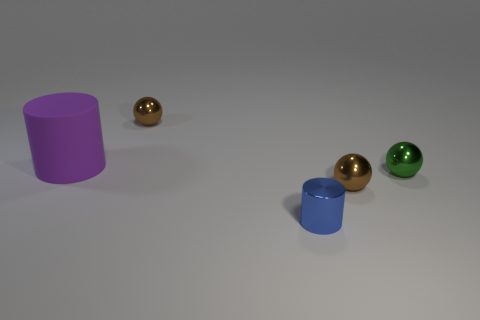Are there an equal number of rubber cylinders that are left of the large matte cylinder and large green rubber spheres?
Offer a terse response. Yes. What number of other things are there of the same material as the small blue cylinder
Offer a terse response. 3. Is the size of the cylinder that is on the right side of the big purple thing the same as the metallic ball that is to the left of the small blue shiny cylinder?
Provide a short and direct response. Yes. What number of objects are either tiny metallic things in front of the big purple cylinder or small brown metallic things behind the green sphere?
Give a very brief answer. 4. Are there any other things that are the same shape as the green thing?
Offer a very short reply. Yes. There is a cylinder left of the tiny blue cylinder; does it have the same color as the shiny thing on the left side of the small blue cylinder?
Your response must be concise. No. How many rubber objects are either green spheres or small blue things?
Your response must be concise. 0. Are there any other things that are the same size as the blue cylinder?
Your answer should be very brief. Yes. What is the shape of the tiny thing in front of the brown object that is in front of the purple matte thing?
Offer a very short reply. Cylinder. Are the brown sphere in front of the purple cylinder and the small brown ball to the left of the small blue cylinder made of the same material?
Provide a succinct answer. Yes. 